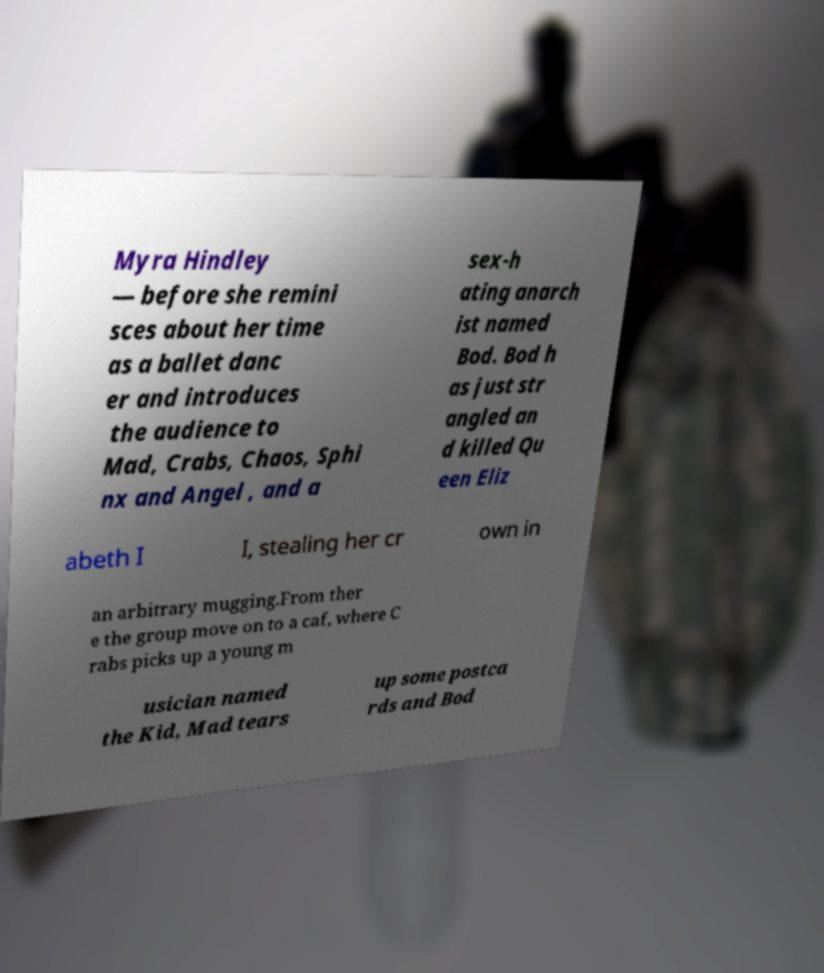Please read and relay the text visible in this image. What does it say? Myra Hindley — before she remini sces about her time as a ballet danc er and introduces the audience to Mad, Crabs, Chaos, Sphi nx and Angel , and a sex-h ating anarch ist named Bod. Bod h as just str angled an d killed Qu een Eliz abeth I I, stealing her cr own in an arbitrary mugging.From ther e the group move on to a caf, where C rabs picks up a young m usician named the Kid, Mad tears up some postca rds and Bod 